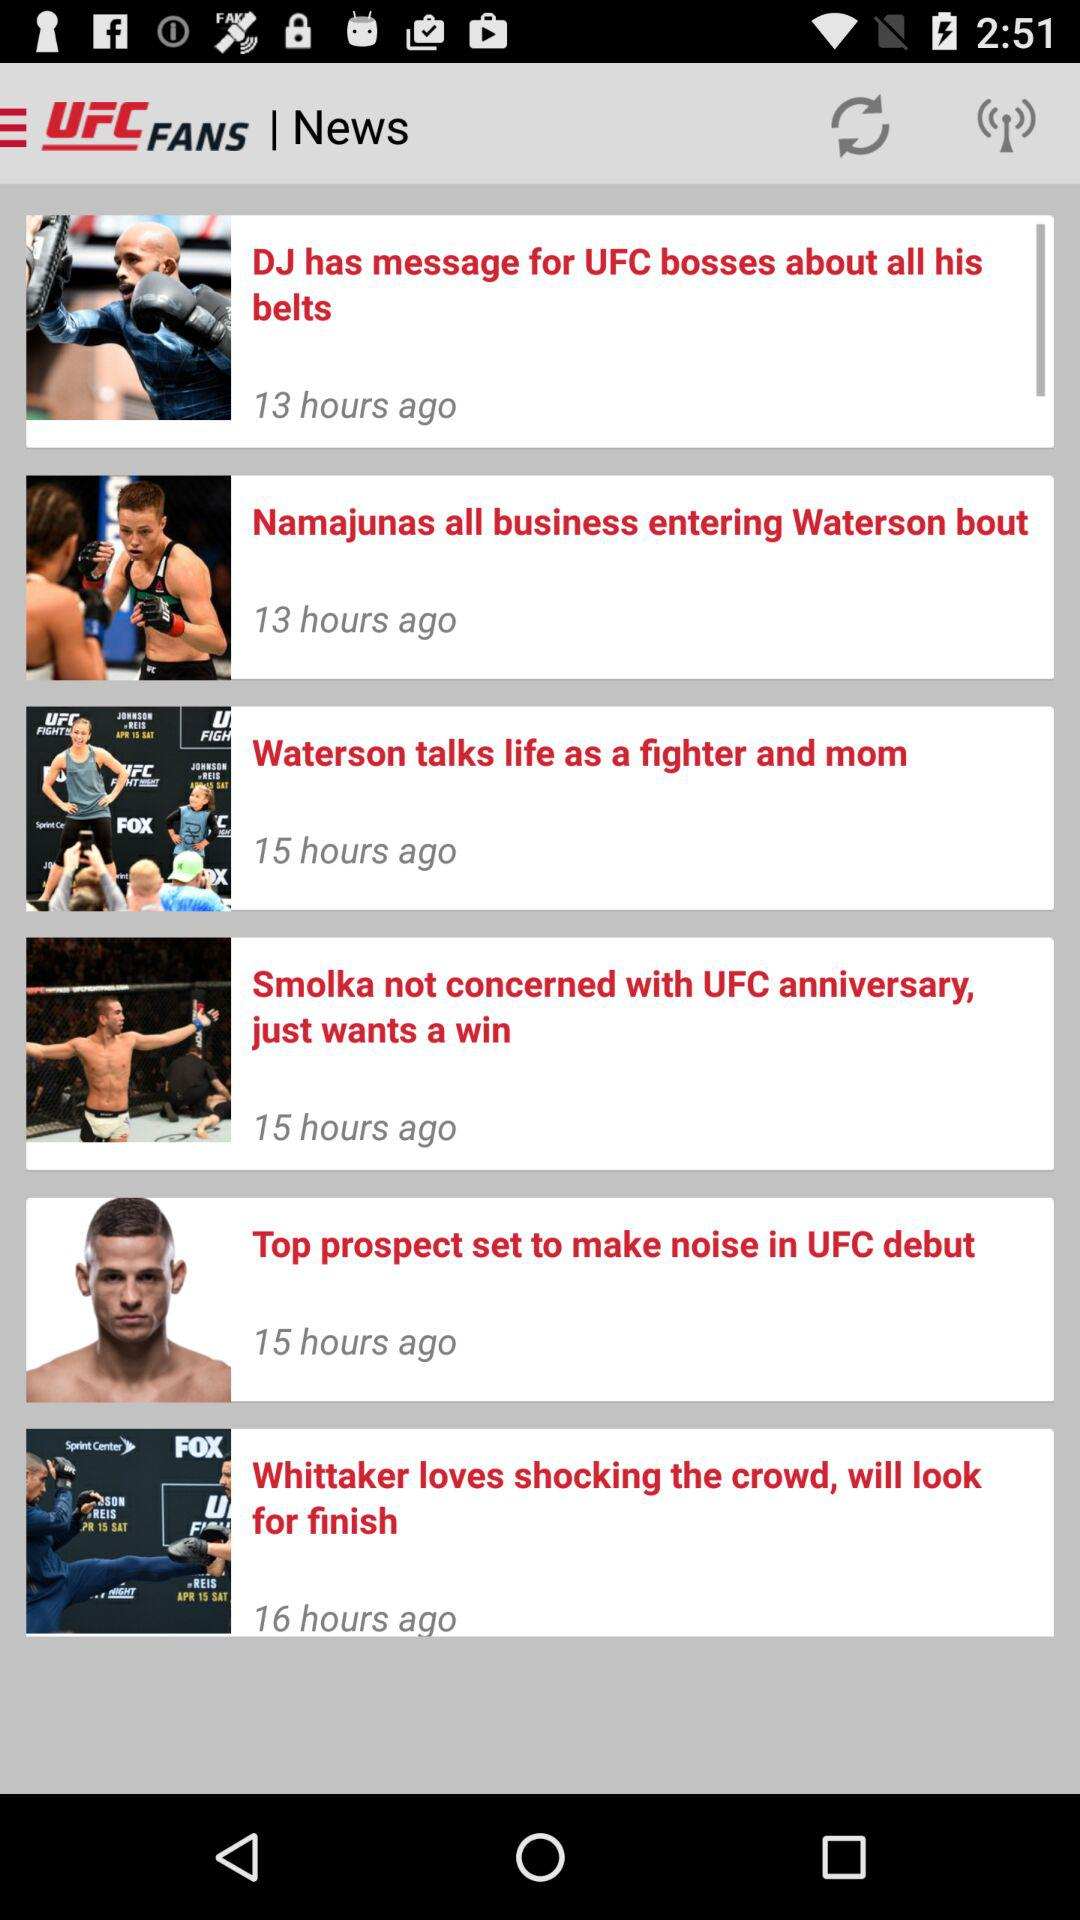When was the article published? The article was published on April 13, 2017. 